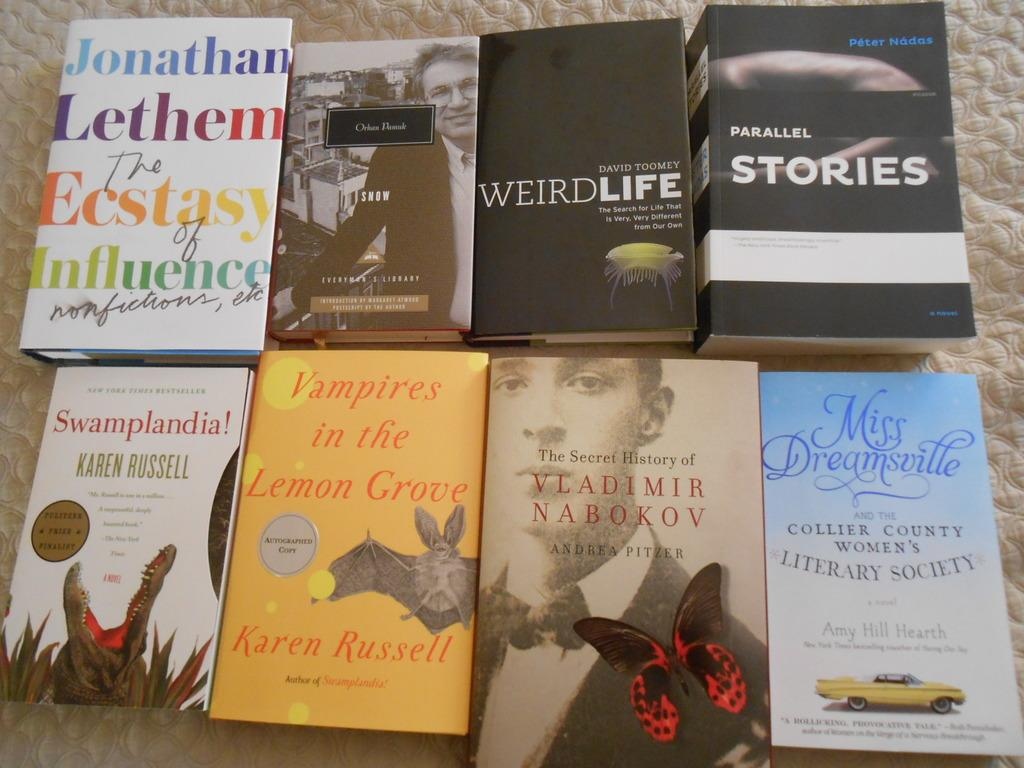<image>
Share a concise interpretation of the image provided. 8 different books are laid out on the cloth with "Parallel Stories" in the right upper corner. 